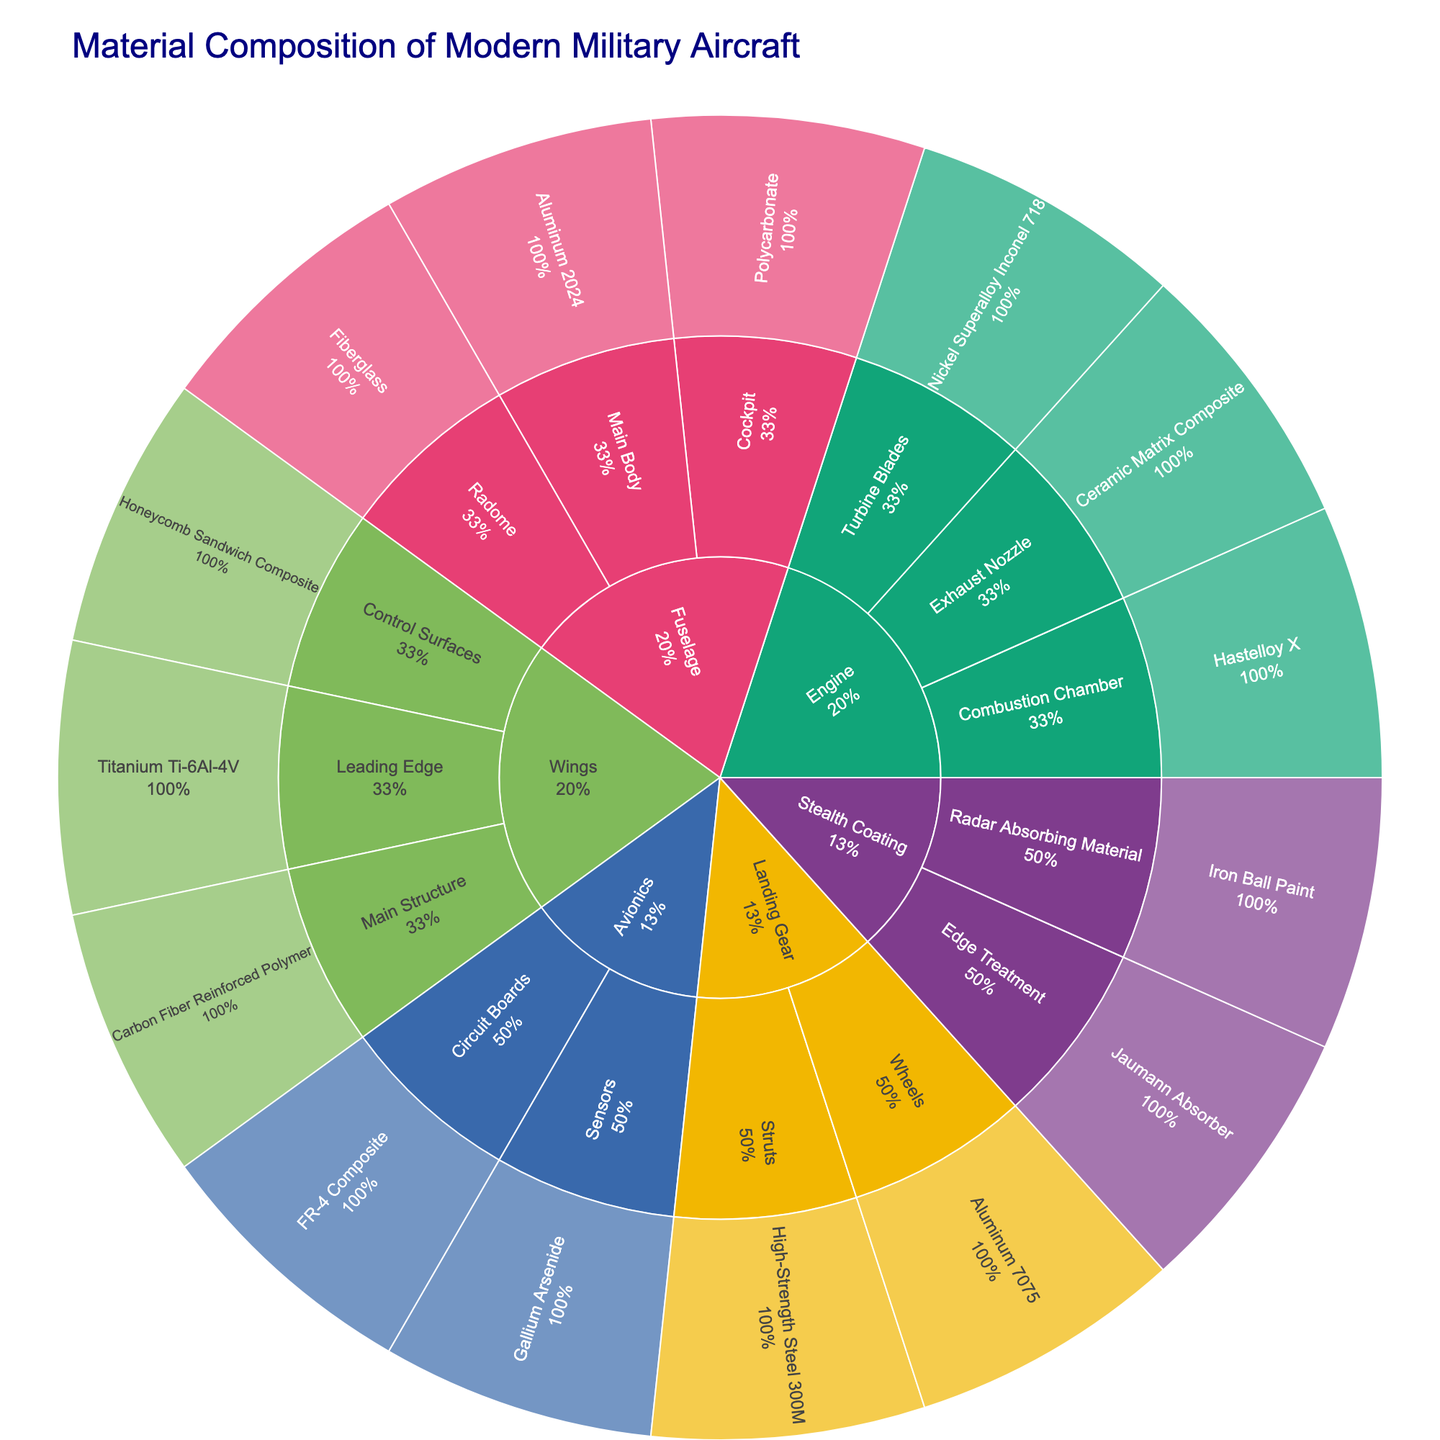What is the title of the figure? The title of the figure is usually shown at the top and summarizes what the plot represents.
Answer: Material Composition of Modern Military Aircraft Which component has the material 'Nickel Superalloy Inconel 718'? Find 'Nickel Superalloy Inconel 718' in the plot and trace back to its parent component.
Answer: Engine What percentage of the Fuselage is represented by 'Aluminum 2024'? Look for 'Aluminum 2024' within the Fuselage segment and note the percentage value.
Answer: It varies depending on visualization but should show as part of Fuselage How many subcomponents are in the Wings component? Count the segments branching from the Wings component in the plot.
Answer: 3 Between the Landing Gear and Avionics, which component has more subcomponents? Compare the number of segments branching from Landing Gear and Avionics.
Answer: Landing Gear What materials make up the stealth coating of the aircraft? Look for the segments under the Stealth Coating component.
Answer: Iron Ball Paint, Jaumann Absorber Which material is used for the Leading Edge of the Wings? Identify the material listed under Wings > Leading Edge in the plot.
Answer: Titanium Ti-6Al-4V Is the material 'FR-4 Composite' used in more than one component? Search the plot for 'FR-4 Composite' and count the number of parent components.
Answer: No Compare the materials used in the Control Surfaces and the Cockpit in terms of composition categories (e.g., polymer, metal, composite). Identify materials under Control Surfaces and Cockpit, then categorize them.
Answer: Control Surfaces: Honeycomb Sandwich Composite. Cockpit: Polycarbonate What ratio is observed between the materials used in the Main Structure of the Wings and the Main Body of the Fuselage? Compare material usage in Wings > Main Structure (Carbon Fiber Reinforced Polymer) and Fuselage > Main Body (Aluminum 2024).
Answer: 1:1 (one material each) 